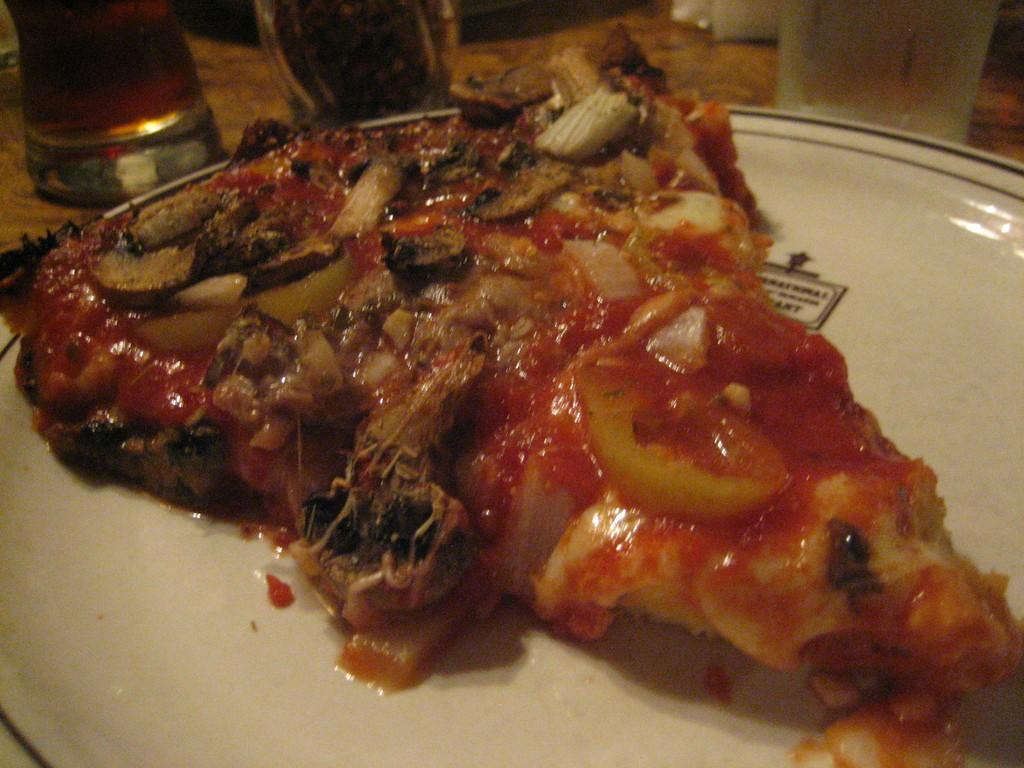What is on the plate that is visible in the image? There is a plate with food in the image. What color is the plate? The plate is white. How would you describe the appearance of the food on the plate? The food is colorful. What else can be seen in the image besides the plate with food? There are glasses in the image. What is the color or material of the surface where the glasses are placed? The glasses are on a brown surface. What type of thing is being shown in the oven in the image? There is no oven present in the image, so it is not possible to answer that question. 